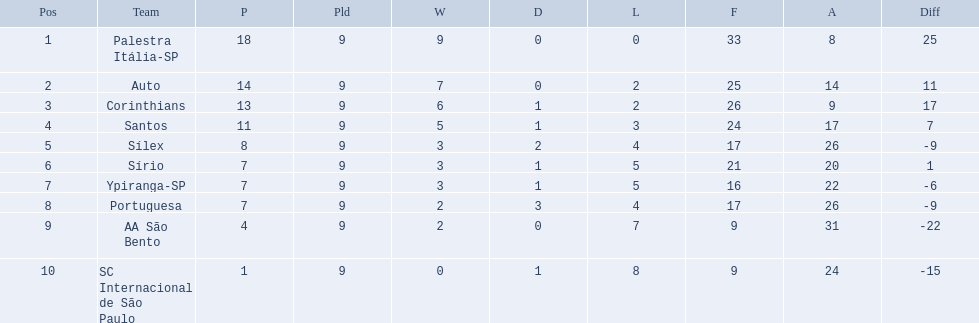What were the top three amounts of games won for 1926 in brazilian football season? 9, 7, 6. What were the top amount of games won for 1926 in brazilian football season? 9. What team won the top amount of games Palestra Itália-SP. 